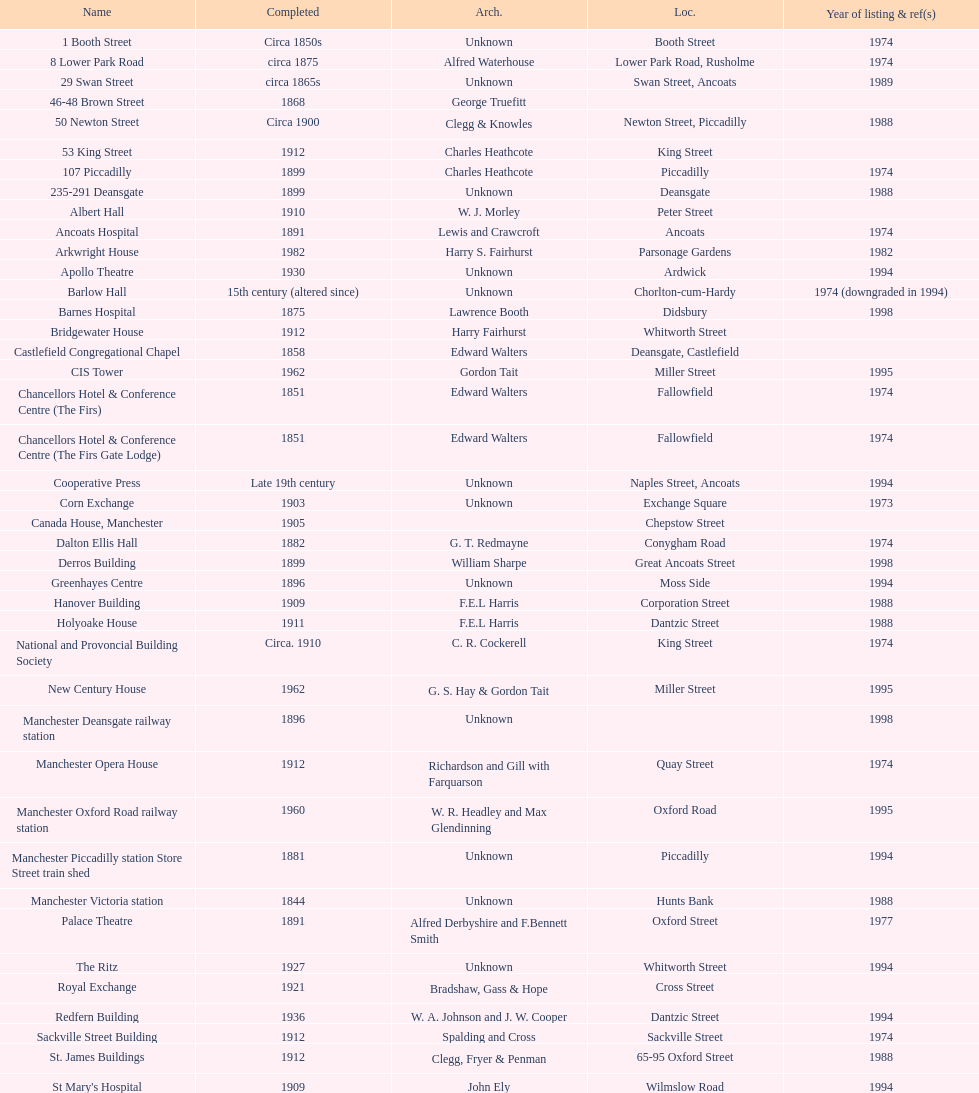How many names are listed with an image? 39. 